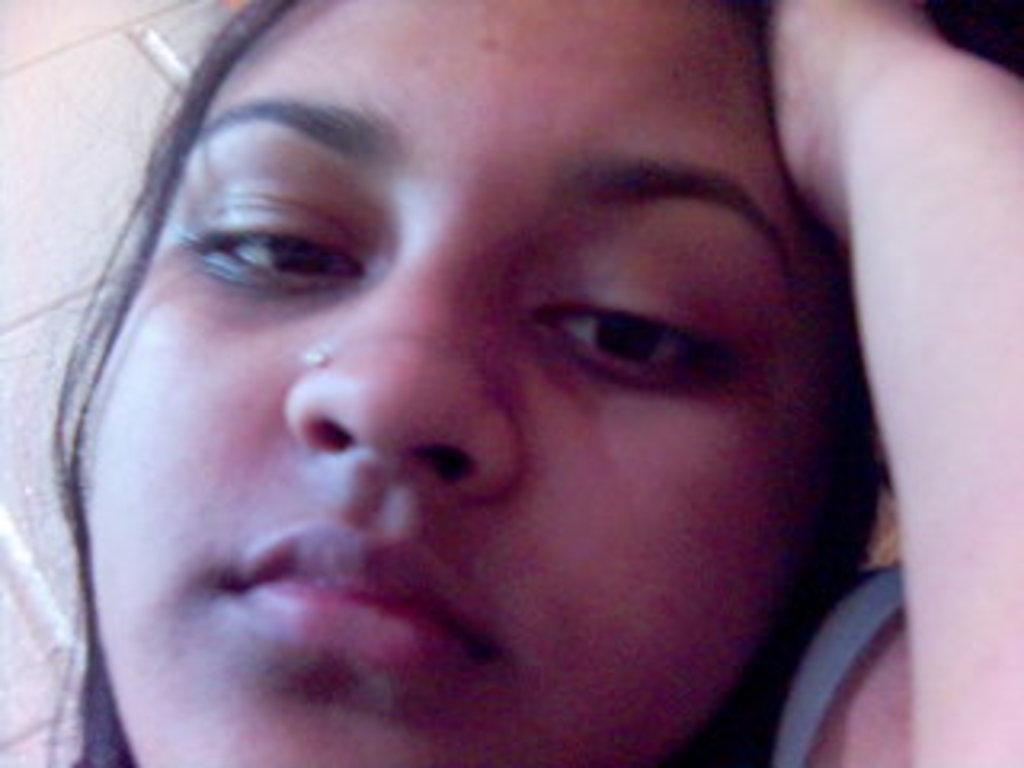Who is present in the image? There is a woman in the image. What can be seen on the left side of the image? There is a wall on the left side of the image. How much money is the woman holding in the image? There is no indication in the image that the woman is holding money. 